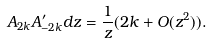Convert formula to latex. <formula><loc_0><loc_0><loc_500><loc_500>A _ { 2 k } A ^ { \prime } _ { - 2 k } d z = \frac { 1 } { z } ( 2 k + O ( z ^ { 2 } ) ) .</formula> 